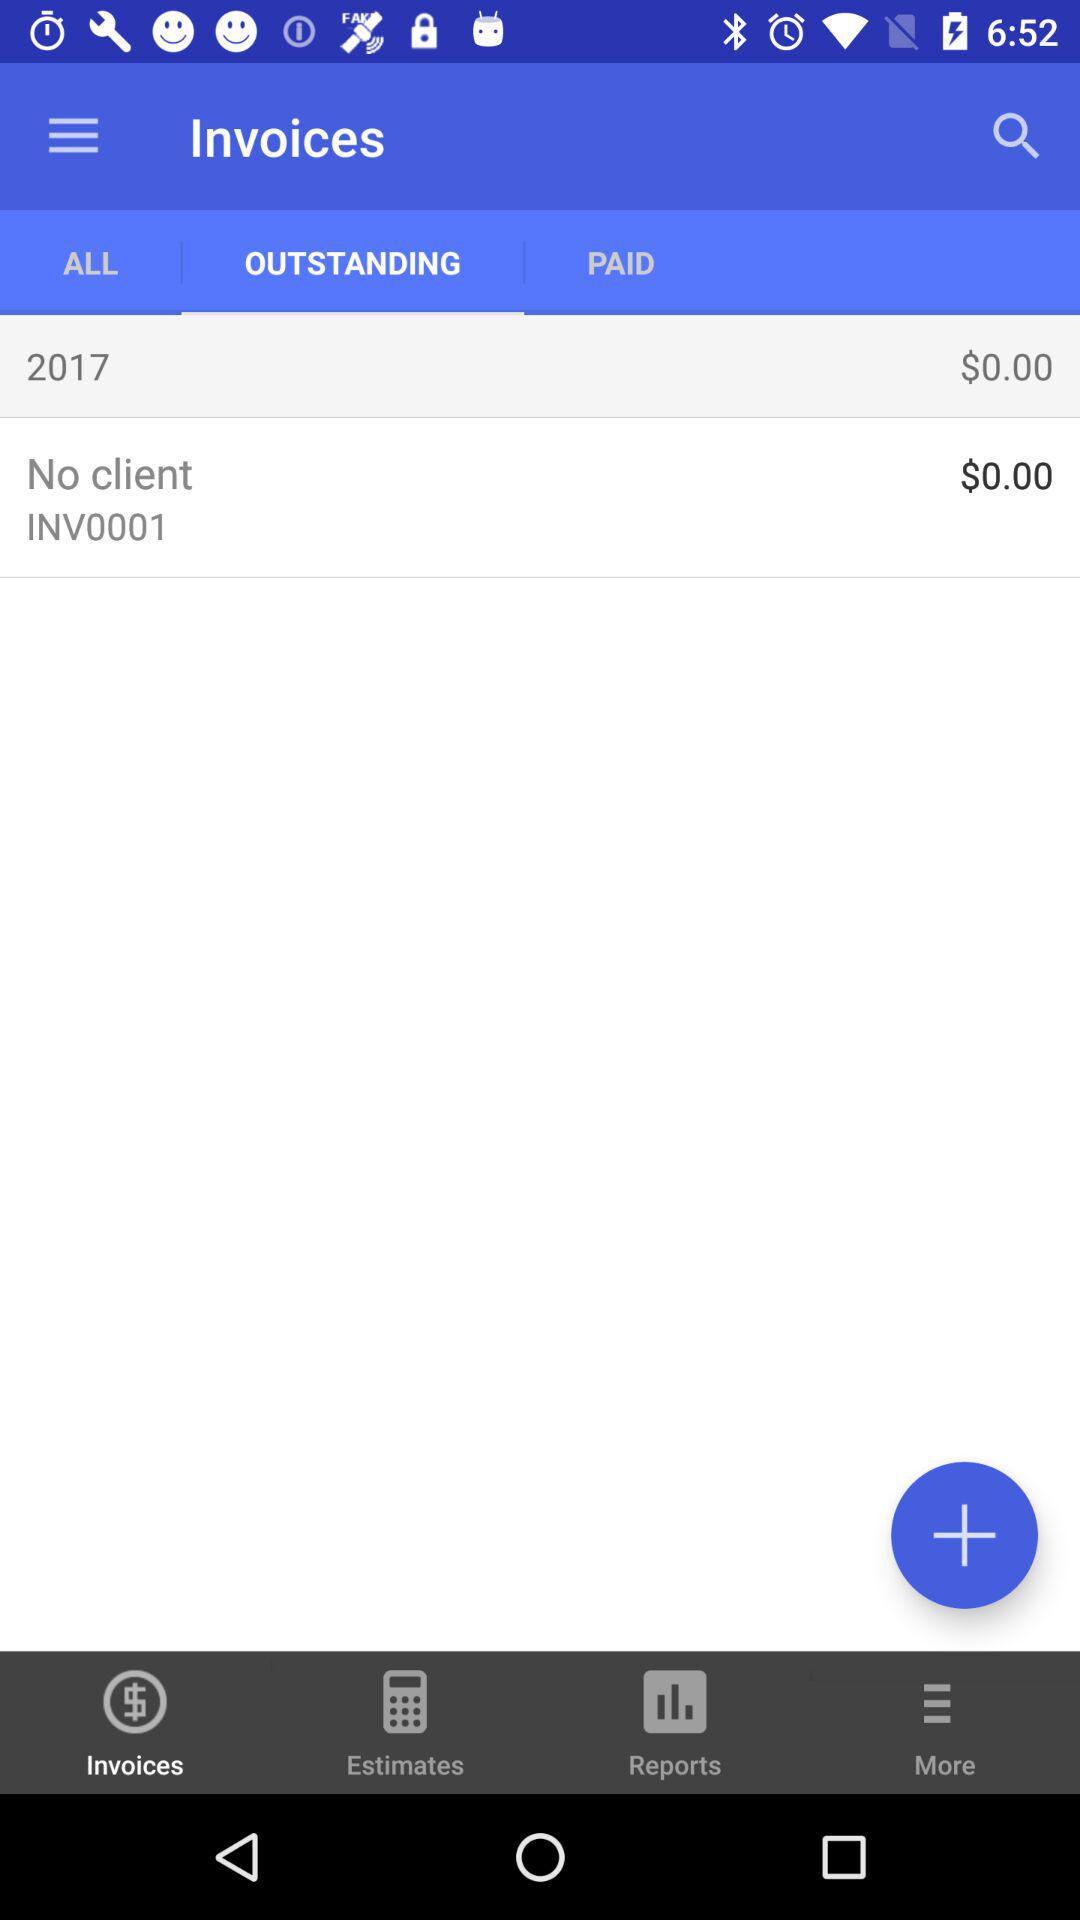How much are the unpaid invoices worth?
Answer the question using a single word or phrase. $0.00 